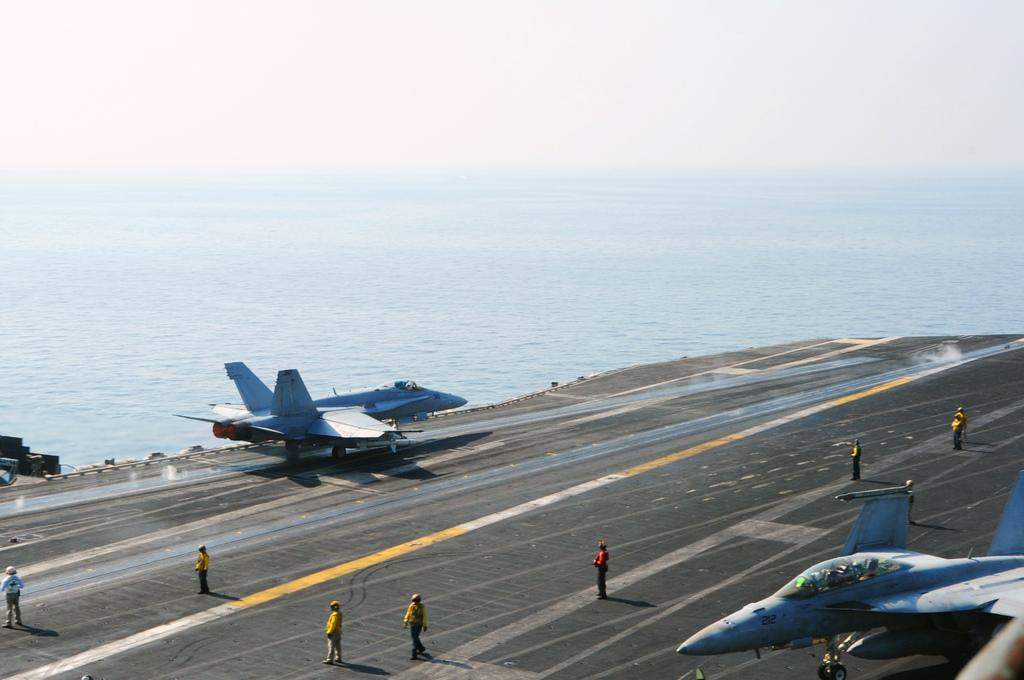Who or what can be seen in the image? There are people and an aircraft in the image. Where are the people and the aircraft located in the image? The people and the aircraft are at the bottom side of the image. What can be seen in the background of the image? There is water visible in the background of the image. How many legs can be seen on the people in the image? The image does not show the legs of the people, so it is impossible to determine the number of legs visible. 